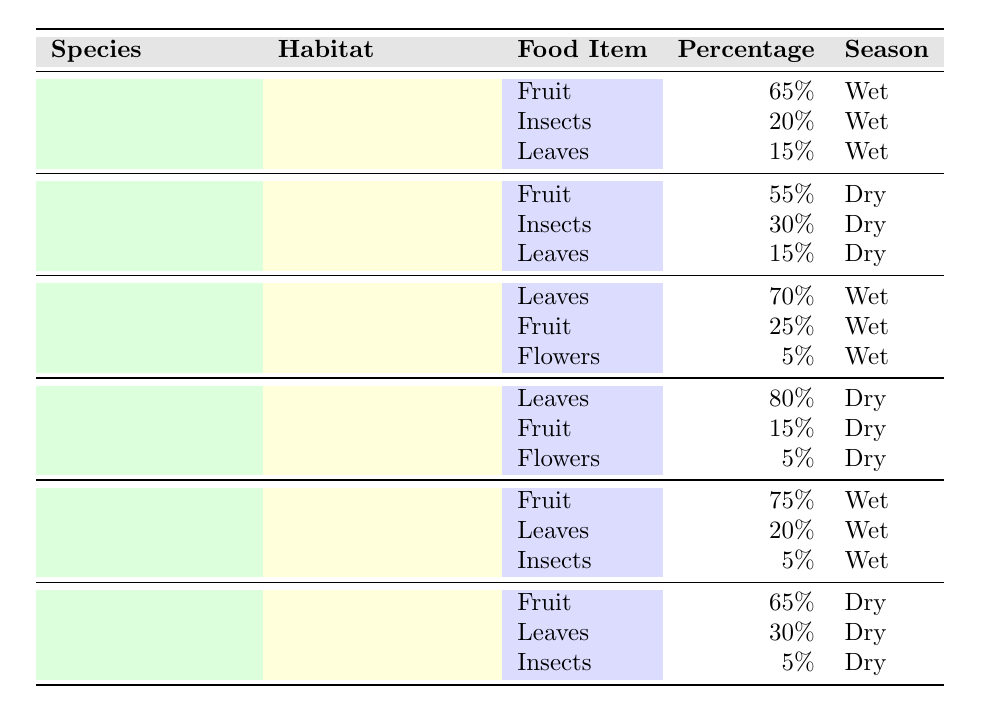What food item do Capuchin monkeys in the Amazon Rainforest consume the most? According to the table, Capuchin monkeys in the Amazon Rainforest consume 65% fruit, which is the highest percentage of any food item listed for this species in that habitat.
Answer: Fruit What is the percentage of leaves in the diet of Howler monkeys in the Cerrado during the dry season? The table indicates that Howler monkeys consume 80% leaves in the Cerrado during the dry season. This is the only food item listed for that season.
Answer: 80% Which monkey species has the highest percentage of fruit consumption during the wet season? By reviewing the table, Spider monkeys have the highest percentage of fruit consumption at 75% in the Amazon Rainforest during the wet season, compared to other species.
Answer: Spider Monkey What is the combined percentage of insects consumed by Spider monkeys in the Amazon Rainforest and Pantanal? For Spider monkeys, the percentage of insects in the Amazon Rainforest is 5% and in the Pantanal is also 5%. Adding these two gives a total of 5 + 5 = 10%.
Answer: 10% Is it true that Howler monkeys consume more leaves than fruit in both the Amazon Rainforest and Cerrado? In the Amazon Rainforest, Howler monkeys consume 70% leaves and 25% fruit, which is more leaves than fruit. In the Cerrado, they consume 80% leaves and 15% fruit, which is again more leaves than fruit. Therefore, the statement is true.
Answer: Yes What is the difference in fruit consumption percentage between Capuchin monkeys in Atlantic Forest during the dry season and Spider monkeys in Pantanal during the dry season? Capuchin monkeys consume 55% fruit in the Atlantic Forest, and Spider monkeys consume 65% fruit in the Pantanal. The difference is 65 - 55 = 10%.
Answer: 10% What percentage of the total diet consists of insects for Capuchin monkeys in both habitats? For Capuchin monkeys in the Amazon Rainforest, the percentage of insects is 20%, and in the Atlantic Forest, it is 30%. Adding these gives a total of 20 + 30 = 50%.
Answer: 50% How does the fruit consumption of Howler monkeys differ between the wet season in the Amazon Rainforest and the dry season in Cerrado? In the Amazon Rainforest during the wet season, Howler monkeys consume 25% fruit, whereas in the Cerrado during the dry season, they consume 15% fruit. The difference is 25 - 15 = 10%.
Answer: 10% 